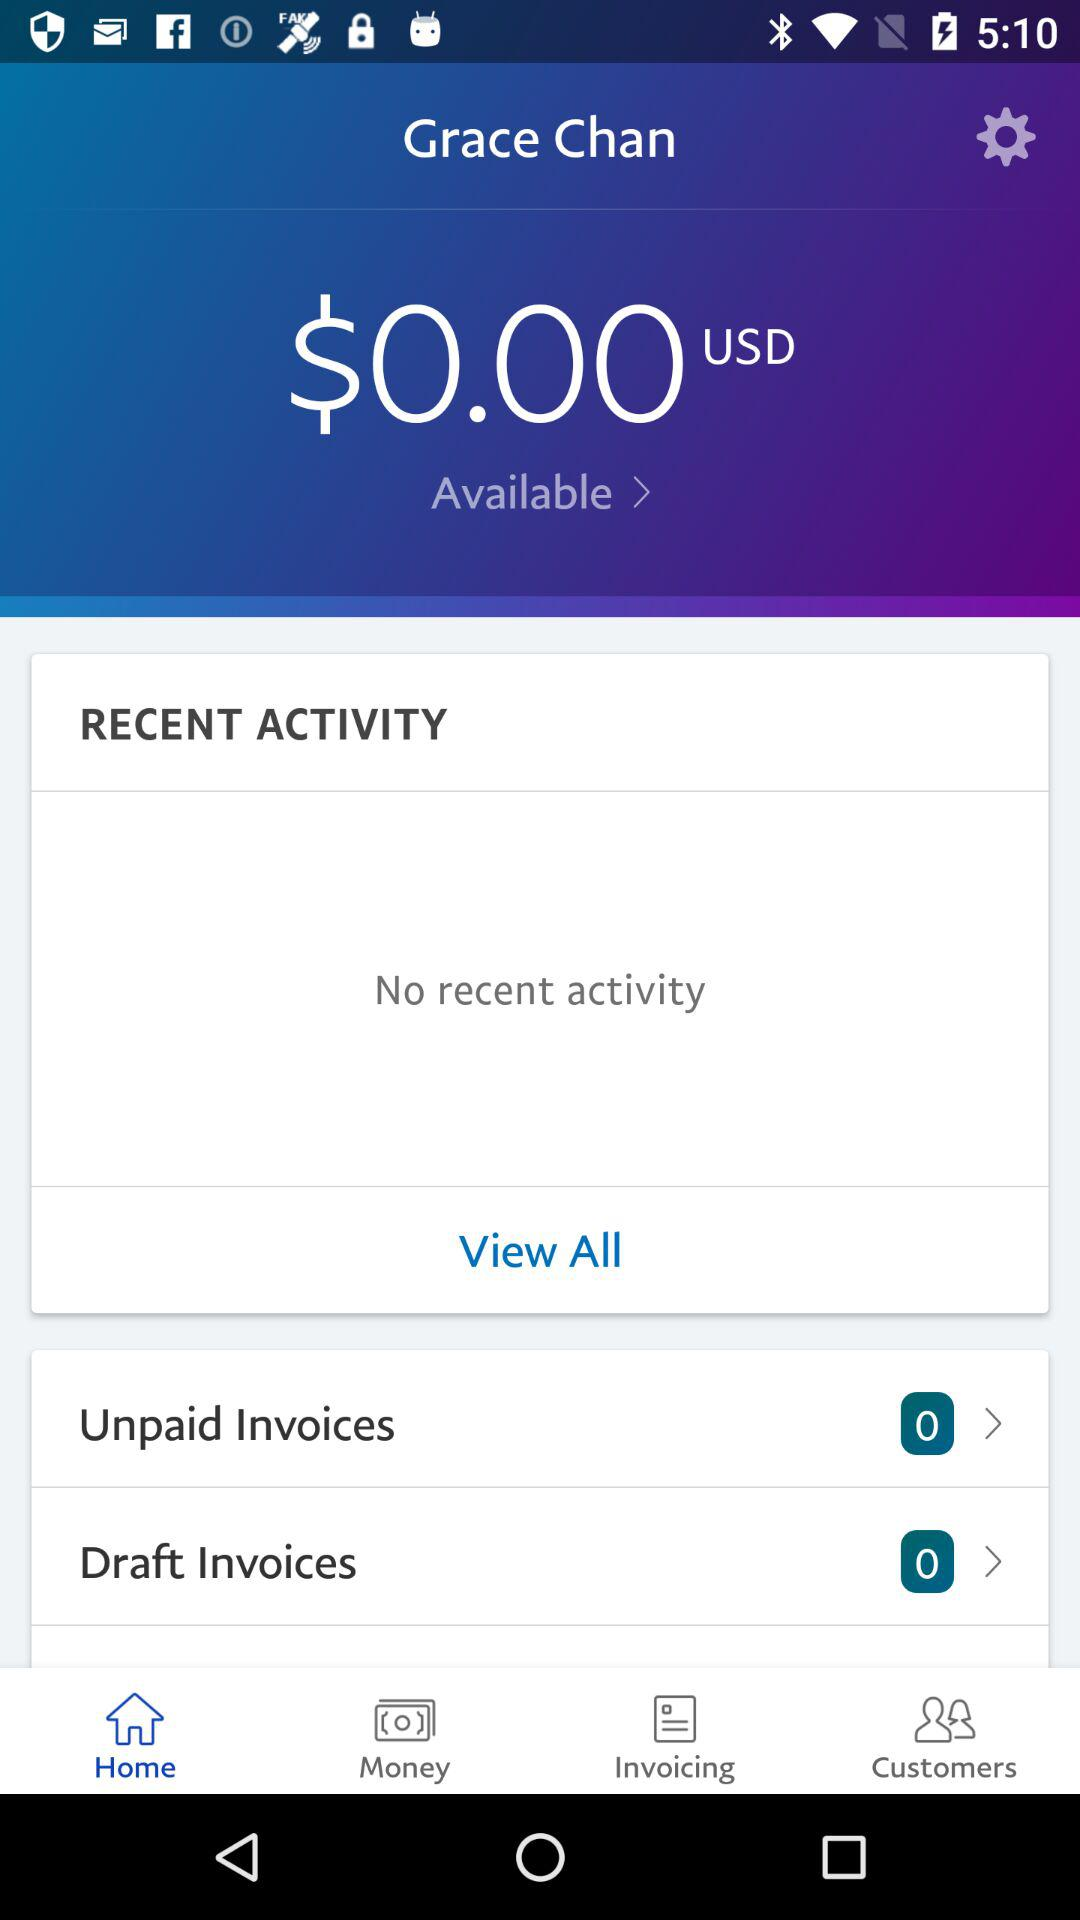How many unpaid invoices are there?
Answer the question using a single word or phrase. 0 